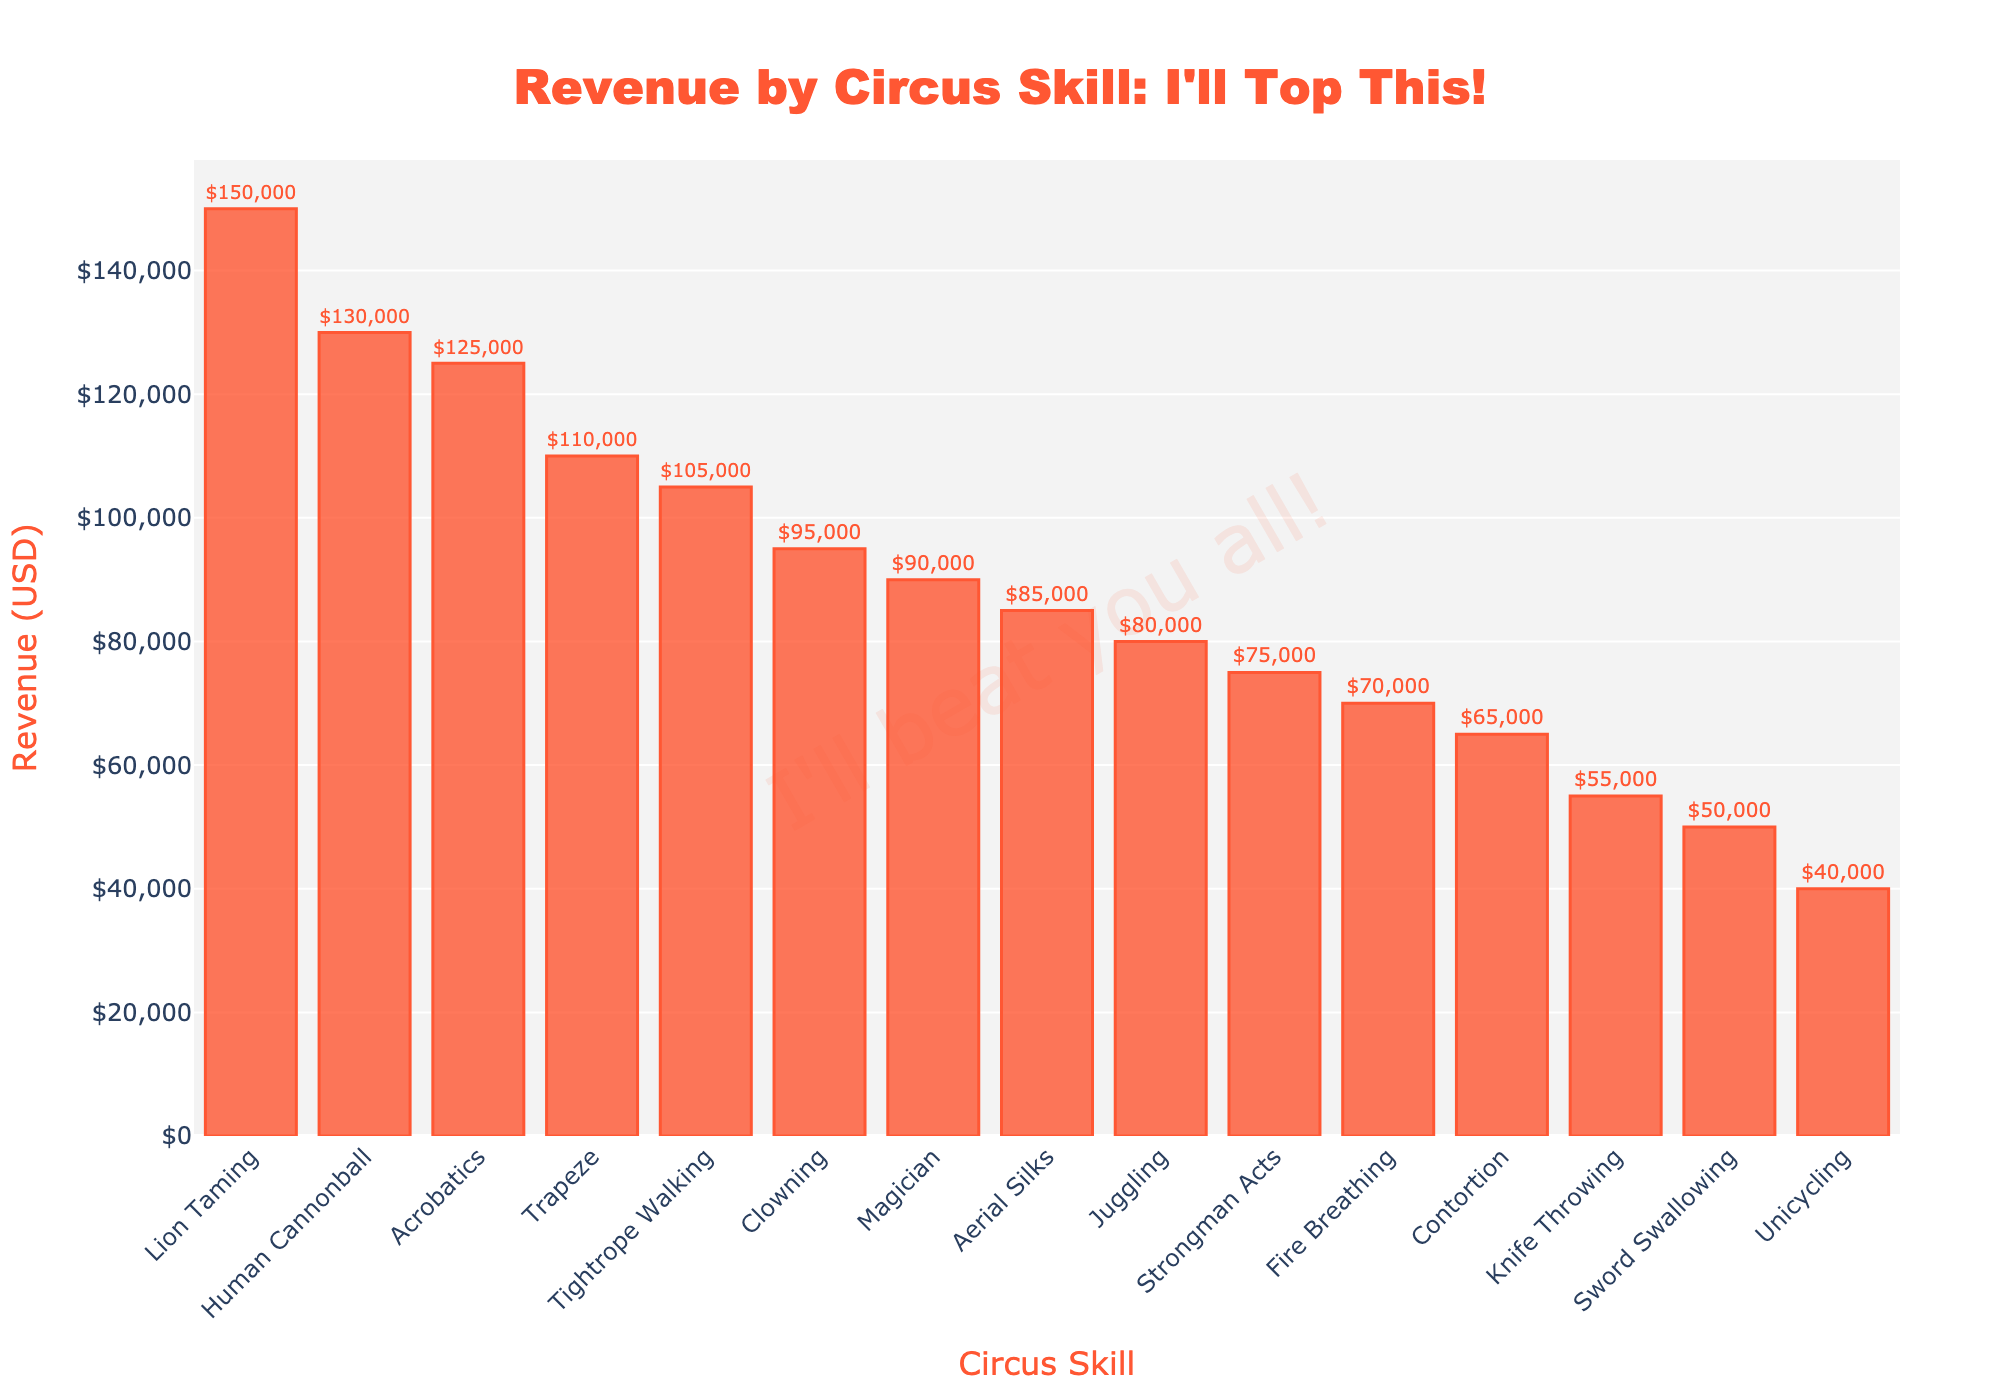What skill generates the highest revenue? The skill generating the highest revenue can be found by identifying the tallest bar in the chart. The tallest bar corresponds to Lion Taming.
Answer: Lion Taming Which two skills generate the least revenue? To find the least revenue-generating skills, look for the shortest bars in the chart. The shortest bars belong to Knife Throwing and Unicycling.
Answer: Knife Throwing and Unicycling How much more revenue does Lion Taming generate compared to Unicycling? Identify the revenue bars for Lion Taming and Unicycling, then calculate the difference. Lion Taming generates $150,000, and Unicycling generates $40,000. The difference is $150,000 - $40,000.
Answer: $110,000 What is the combined revenue of Acrobatics, Trapeze, and Human Cannonball? Add the revenue values of Acrobatics ($125,000), Trapeze ($110,000), and Human Cannonball ($130,000) from their respective bars. $125,000 + $110,000 + $130,000 = $365,000.
Answer: $365,000 Which skill performs better in terms of revenue: Tightrope Walking or Clowning? Compare the heights of the bars representing Tightrope Walking and Clowning. Tightrope Walking generates $105,000, while Clowning generates $95,000.
Answer: Tightrope Walking What is the total revenue generated by skills with a revenue less than $100,000? Sum the revenue values of skills whose bars are less than $100,000: Clowning ($95,000), Juggling ($80,000), Fire Breathing ($70,000), Contortion ($65,000), Knife Throwing ($55,000), Unicycling ($40,000), Aerial Silks ($85,000), Sword Swallowing ($50,000), and Strongman Acts ($75,000). $95,000 + $80,000 + $70,000 + $65,000 + $55,000 + $40,000 + $85,000 + $50,000 + $75,000 = $615,000.
Answer: $615,000 What is the average revenue of all the skills presented? Sum the revenue of all skills, then divide by the total number of skills. The sum is $125,000 + $110,000 + $95,000 + $80,000 + $150,000 + $70,000 + $105,000 + $65,000 + $55,000 + $40,000 + $85,000 + $50,000 + $75,000 + $90,000 + $130,000 = $1,225,000. There are 15 skills, so the average is $1,225,000 / 15.
Answer: $81,667 Which skill's revenue is closest to the median revenue value? First, arrange the revenue values in ascending order and find the median: $40,000, $50,000, $55,000, $65,000, $70,000, $75,000, $80,000, $85,000, $90,000, $95,000, $105,000, $110,000, $125,000, $130,000, $150,000. The median revenue value is the 8th value: $85,000. The skill with exactly $85,000 revenue is Aerial Silks.
Answer: Aerial Silks 